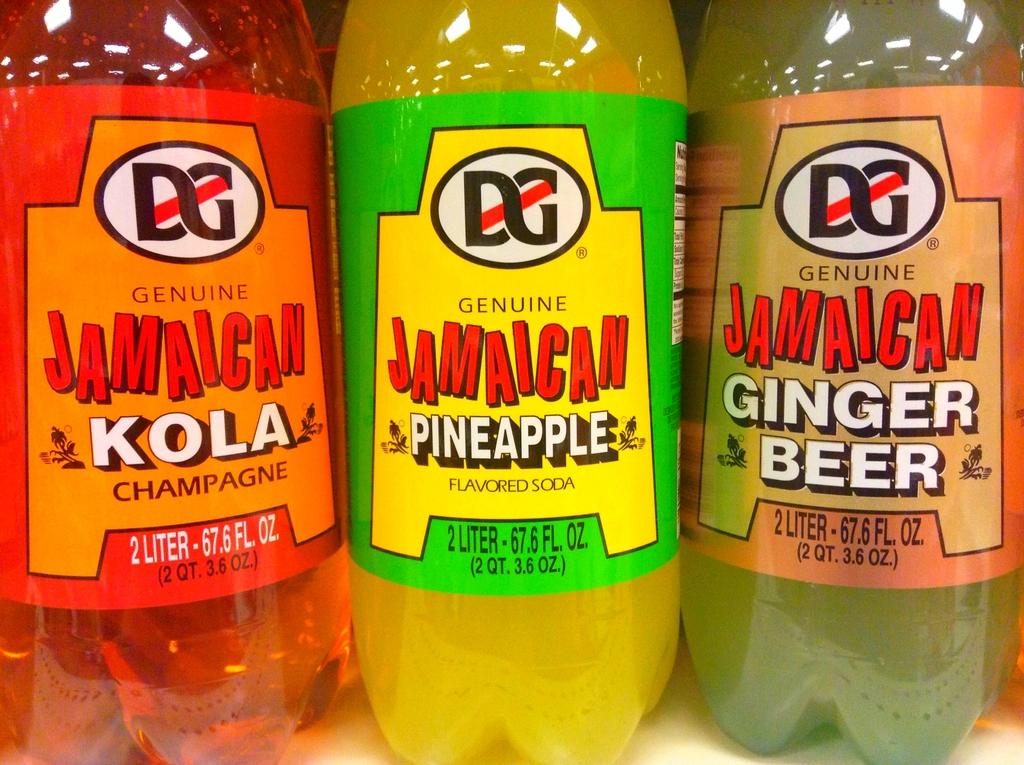<image>
Provide a brief description of the given image. The genuine Jamaican brand drinks displayed in the quantity of 2 liter 